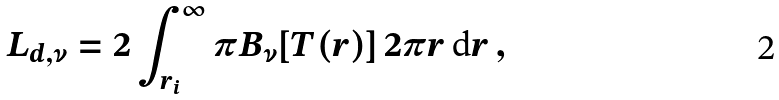Convert formula to latex. <formula><loc_0><loc_0><loc_500><loc_500>L _ { d , \nu } = 2 \int ^ { \infty } _ { r _ { i } } \pi B _ { \nu } [ T ( r ) ] \, 2 \pi r \, \text {d} r \, ,</formula> 